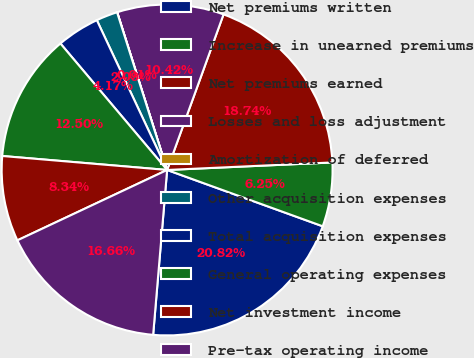Convert chart to OTSL. <chart><loc_0><loc_0><loc_500><loc_500><pie_chart><fcel>Net premiums written<fcel>Increase in unearned premiums<fcel>Net premiums earned<fcel>Losses and loss adjustment<fcel>Amortization of deferred<fcel>Other acquisition expenses<fcel>Total acquisition expenses<fcel>General operating expenses<fcel>Net investment income<fcel>Pre-tax operating income<nl><fcel>20.82%<fcel>6.25%<fcel>18.74%<fcel>10.42%<fcel>0.01%<fcel>2.09%<fcel>4.17%<fcel>12.5%<fcel>8.34%<fcel>16.66%<nl></chart> 